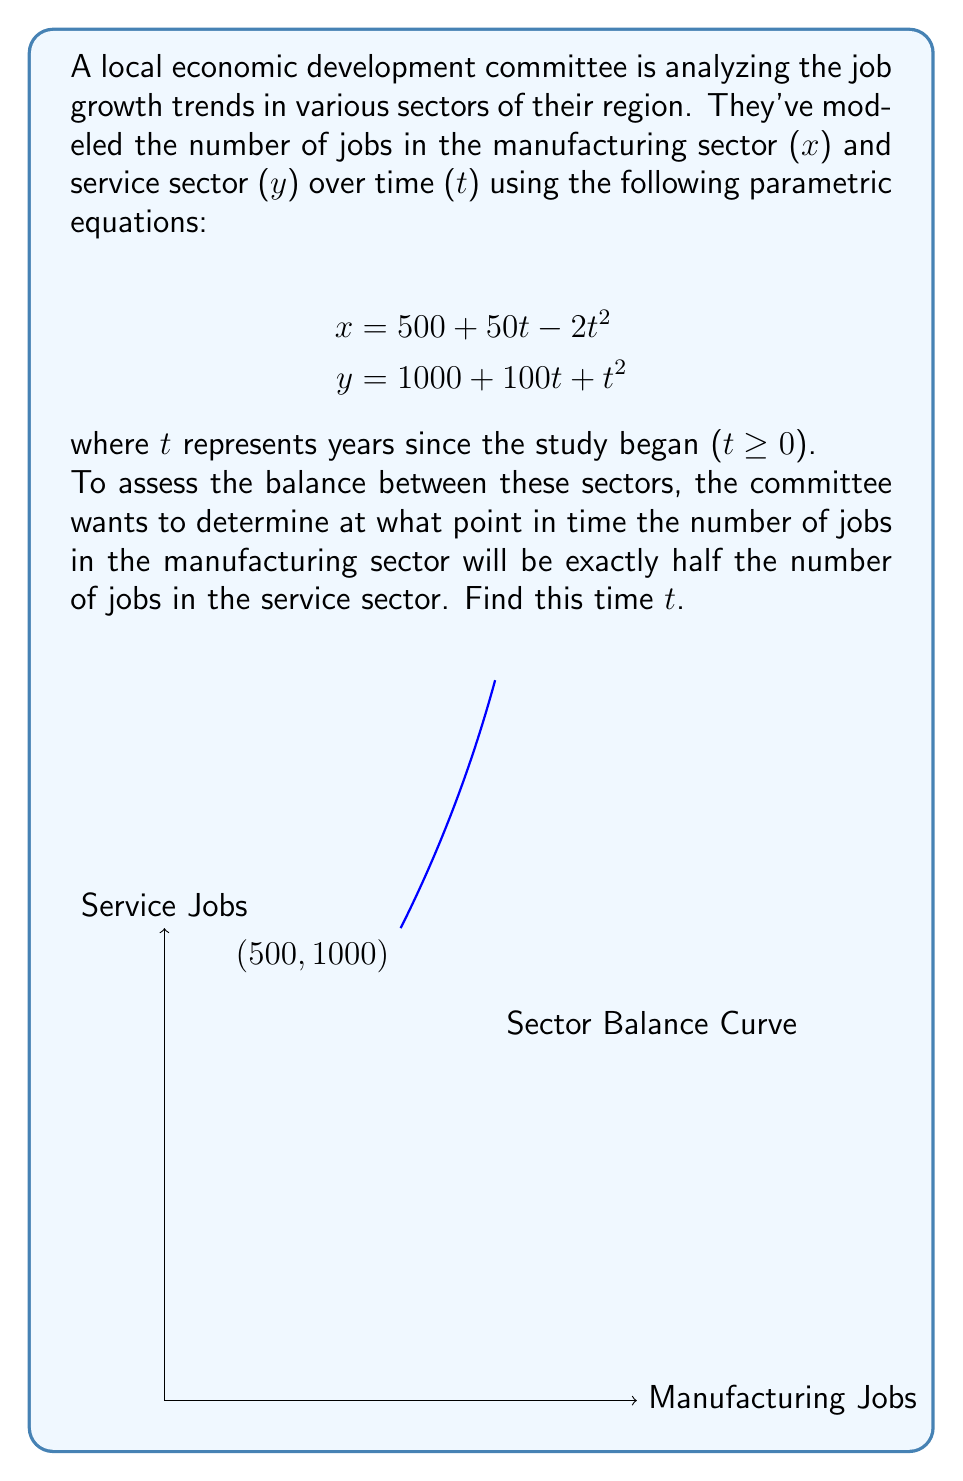What is the answer to this math problem? Let's approach this step-by-step:

1) We need to find t when x = 0.5y. Let's set up this equation:

   $$500 + 50t - 2t^2 = 0.5(1000 + 100t + t^2)$$

2) Expand the right side:

   $$500 + 50t - 2t^2 = 500 + 50t + 0.5t^2$$

3) Subtract the left side from both sides:

   $$0 = 500 + 50t + 0.5t^2 - (500 + 50t - 2t^2)$$

4) Simplify:

   $$0 = 0.5t^2 + 2t^2 = 2.5t^2$$

5) Divide both sides by 2.5:

   $$0 = t^2$$

6) Take the square root of both sides:

   $$t = 0$$

7) Check if this solution makes sense in the context:

   At t = 0:
   x = 500 + 50(0) - 2(0)^2 = 500
   y = 1000 + 100(0) + (0)^2 = 1000

   Indeed, 500 is half of 1000, so this solution is valid.
Answer: t = 0 